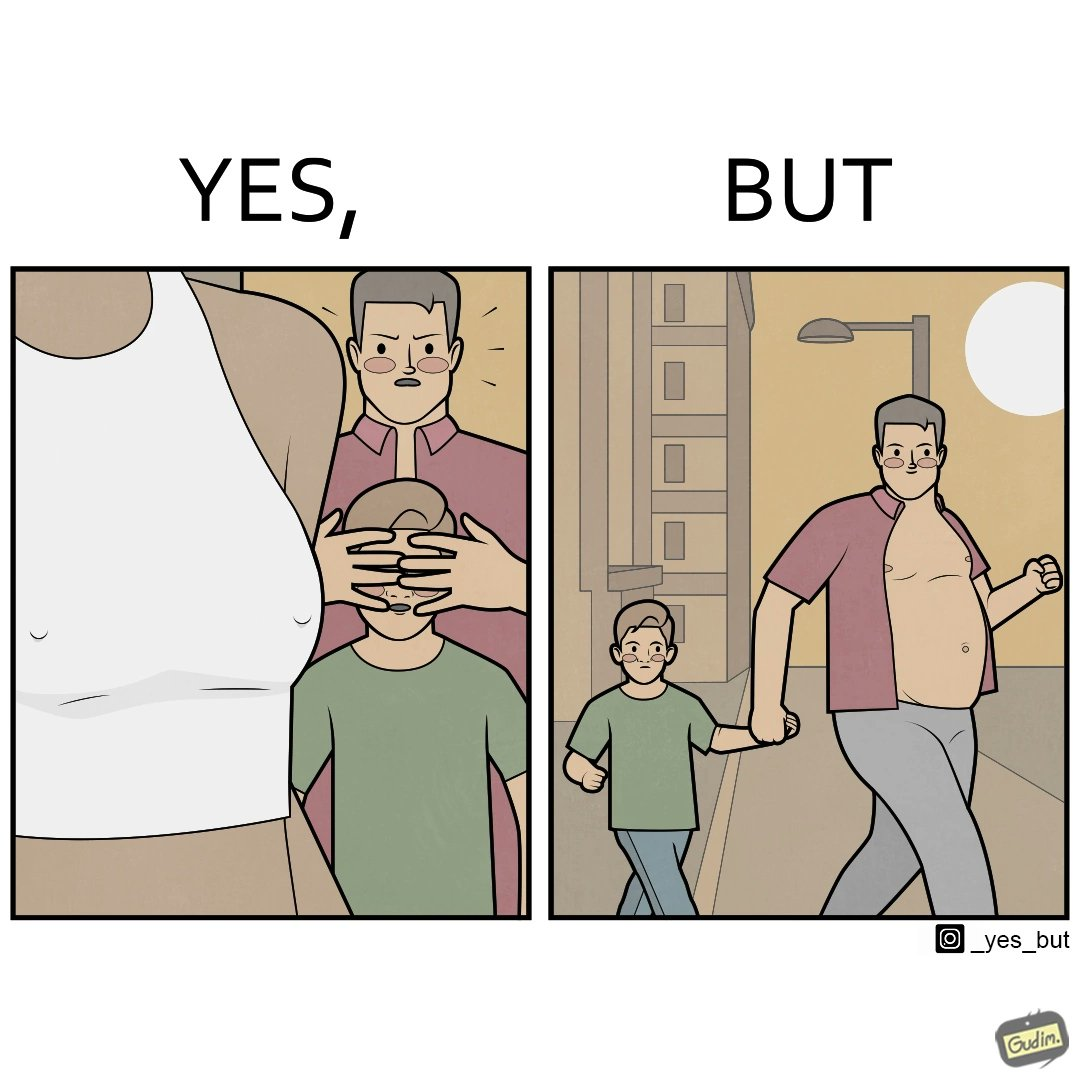Would you classify this image as satirical? Yes, this image is satirical. 